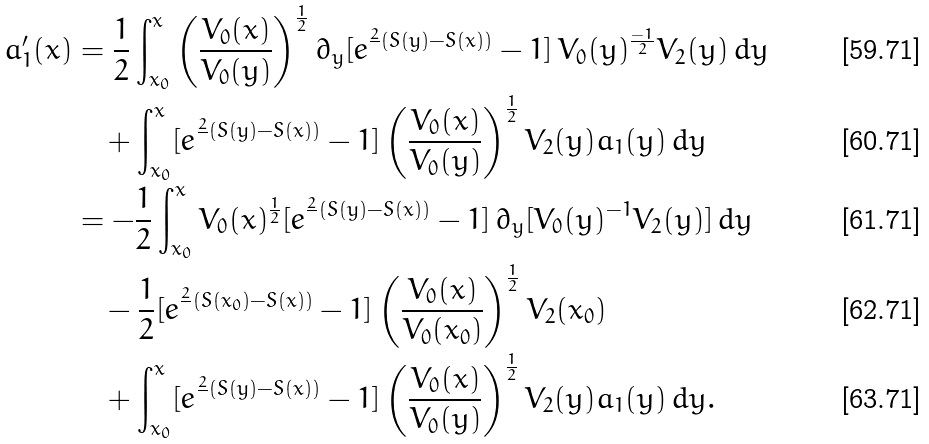Convert formula to latex. <formula><loc_0><loc_0><loc_500><loc_500>a _ { 1 } ^ { \prime } ( x ) & = \frac { 1 } { 2 } \int _ { x _ { 0 } } ^ { x } \left ( \frac { V _ { 0 } ( x ) } { V _ { 0 } ( y ) } \right ) ^ { \frac { 1 } { 2 } } \partial _ { y } [ e ^ { \frac { 2 } { } ( S ( y ) - S ( x ) ) } - 1 ] \, V _ { 0 } ( y ) ^ { \frac { - 1 } { 2 } } V _ { 2 } ( y ) \, d y \\ & \quad + \int _ { x _ { 0 } } ^ { x } [ e ^ { \frac { 2 } { } ( S ( y ) - S ( x ) ) } - 1 ] \left ( \frac { V _ { 0 } ( x ) } { V _ { 0 } ( y ) } \right ) ^ { \frac { 1 } { 2 } } V _ { 2 } ( y ) a _ { 1 } ( y ) \, d y \\ & = - \frac { 1 } { 2 } \int _ { x _ { 0 } } ^ { x } V _ { 0 } ( x ) ^ { \frac { 1 } { 2 } } [ e ^ { \frac { 2 } { } ( S ( y ) - S ( x ) ) } - 1 ] \, \partial _ { y } [ V _ { 0 } ( y ) ^ { - 1 } V _ { 2 } ( y ) ] \, d y \\ & \quad - \frac { 1 } { 2 } [ e ^ { \frac { 2 } { } ( S ( x _ { 0 } ) - S ( x ) ) } - 1 ] \left ( \frac { V _ { 0 } ( x ) } { V _ { 0 } ( x _ { 0 } ) } \right ) ^ { \frac { 1 } { 2 } } V _ { 2 } ( x _ { 0 } ) \\ & \quad + \int _ { x _ { 0 } } ^ { x } [ e ^ { \frac { 2 } { } ( S ( y ) - S ( x ) ) } - 1 ] \left ( \frac { V _ { 0 } ( x ) } { V _ { 0 } ( y ) } \right ) ^ { \frac { 1 } { 2 } } V _ { 2 } ( y ) a _ { 1 } ( y ) \, d y .</formula> 